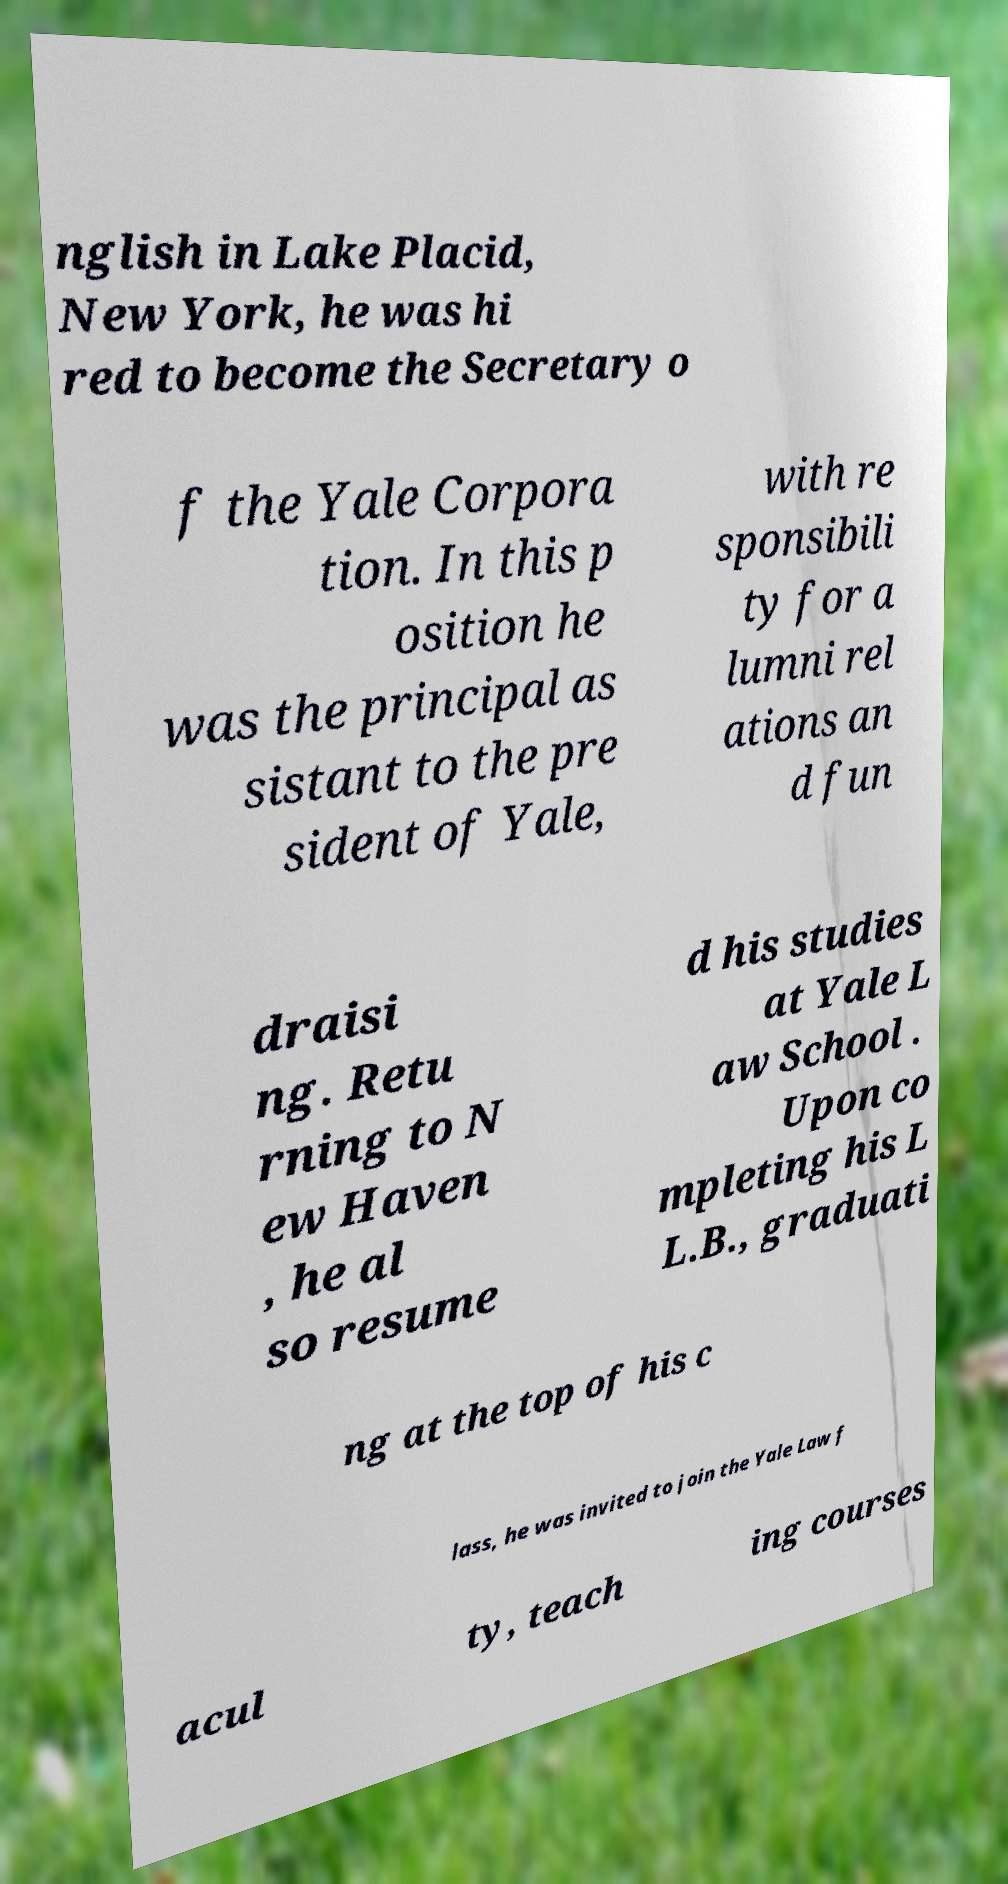Can you accurately transcribe the text from the provided image for me? nglish in Lake Placid, New York, he was hi red to become the Secretary o f the Yale Corpora tion. In this p osition he was the principal as sistant to the pre sident of Yale, with re sponsibili ty for a lumni rel ations an d fun draisi ng. Retu rning to N ew Haven , he al so resume d his studies at Yale L aw School . Upon co mpleting his L L.B., graduati ng at the top of his c lass, he was invited to join the Yale Law f acul ty, teach ing courses 